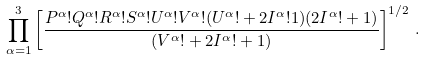Convert formula to latex. <formula><loc_0><loc_0><loc_500><loc_500>\prod _ { \alpha = 1 } ^ { 3 } \left [ { \frac { P ^ { \alpha } ! Q ^ { \alpha } ! R ^ { \alpha } ! S ^ { \alpha } ! U ^ { \alpha } ! V ^ { \alpha } ! ( U ^ { \alpha } ! + 2 I ^ { \alpha } ! 1 ) ( 2 I ^ { \alpha } ! + 1 ) } { ( V ^ { \alpha } ! + 2 I ^ { \alpha } ! + 1 ) } } \right ] ^ { 1 / 2 } \, .</formula> 